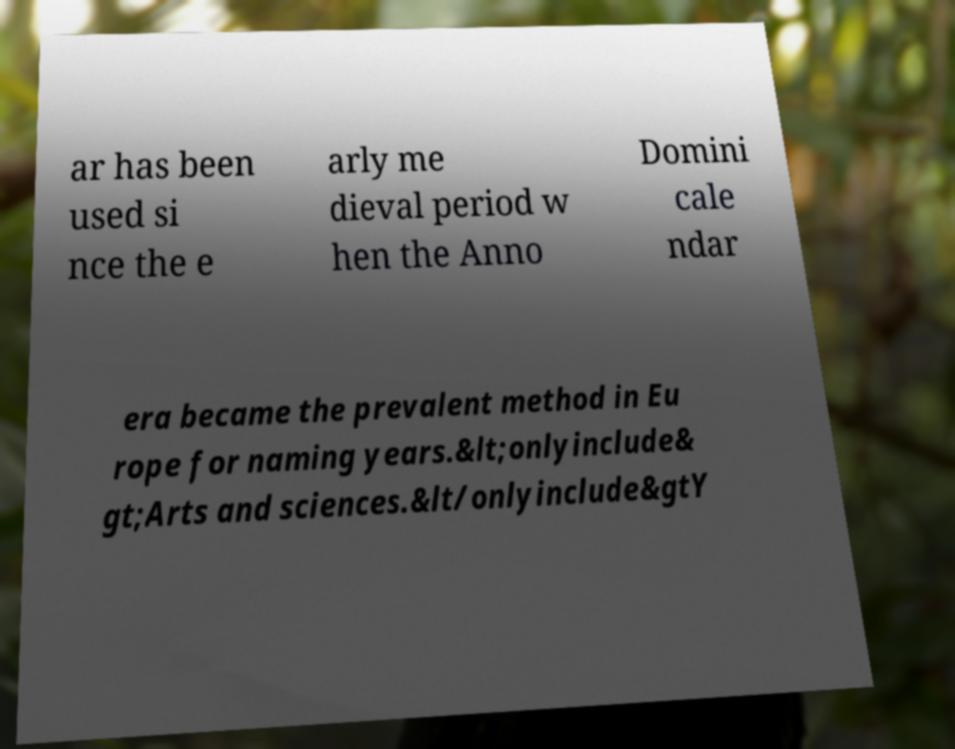I need the written content from this picture converted into text. Can you do that? ar has been used si nce the e arly me dieval period w hen the Anno Domini cale ndar era became the prevalent method in Eu rope for naming years.&lt;onlyinclude& gt;Arts and sciences.&lt/onlyinclude&gtY 